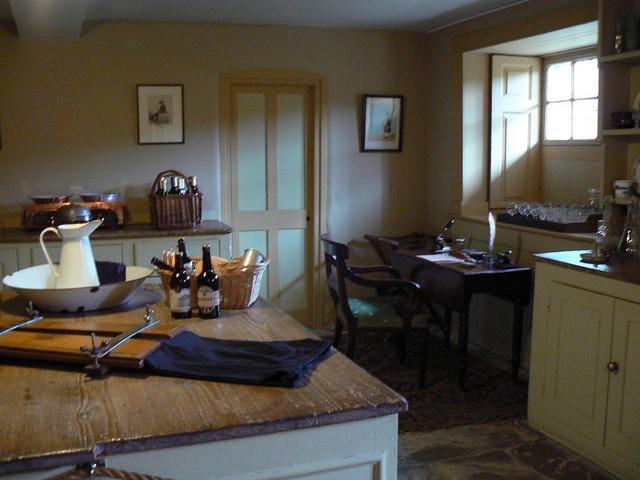How many bowls are in the photo?
Give a very brief answer. 1. How many baby zebras in this picture?
Give a very brief answer. 0. 